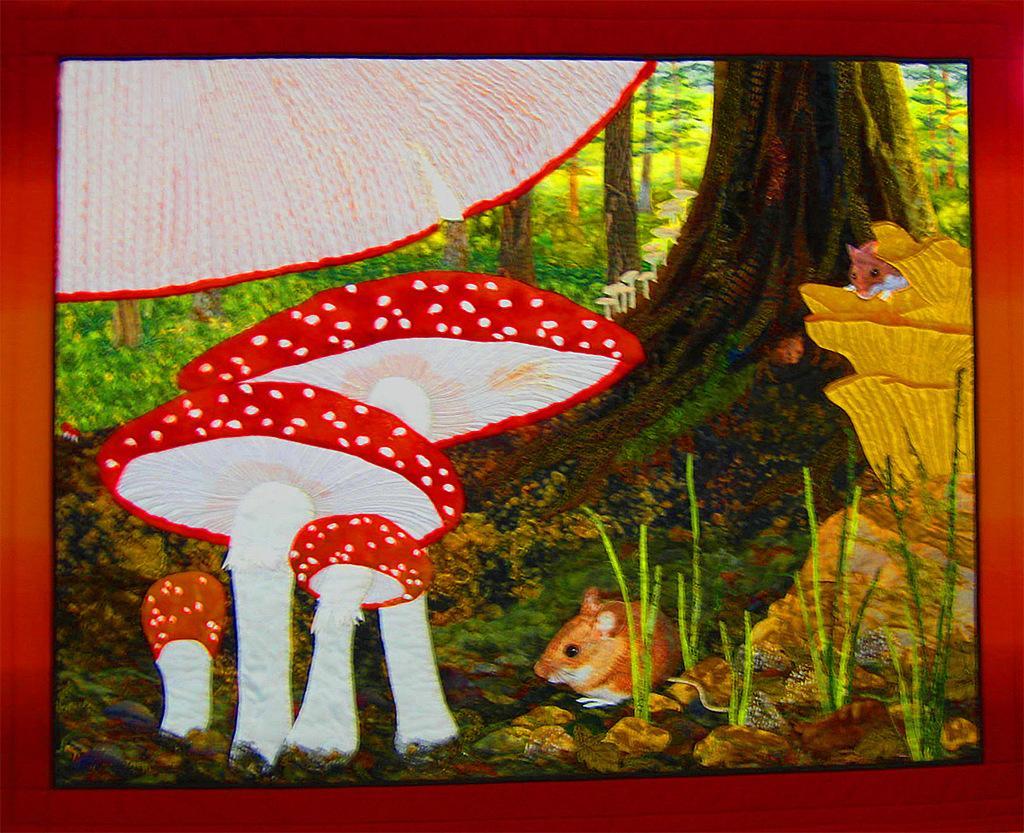How would you summarize this image in a sentence or two? In this image I can see painting of trees, a mouse, mushrooms and other things. 